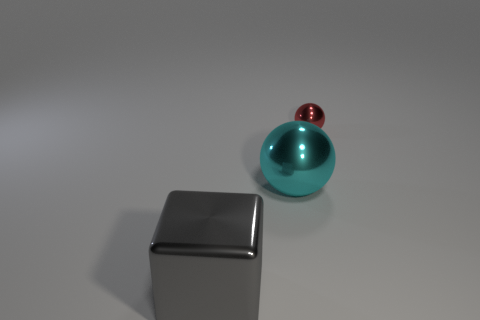Subtract all yellow blocks. Subtract all cyan cylinders. How many blocks are left? 1 Add 3 large brown matte blocks. How many objects exist? 6 Subtract all cubes. How many objects are left? 2 Add 3 large gray things. How many large gray things are left? 4 Add 2 metal balls. How many metal balls exist? 4 Subtract 0 brown spheres. How many objects are left? 3 Subtract all big metallic balls. Subtract all green metal spheres. How many objects are left? 2 